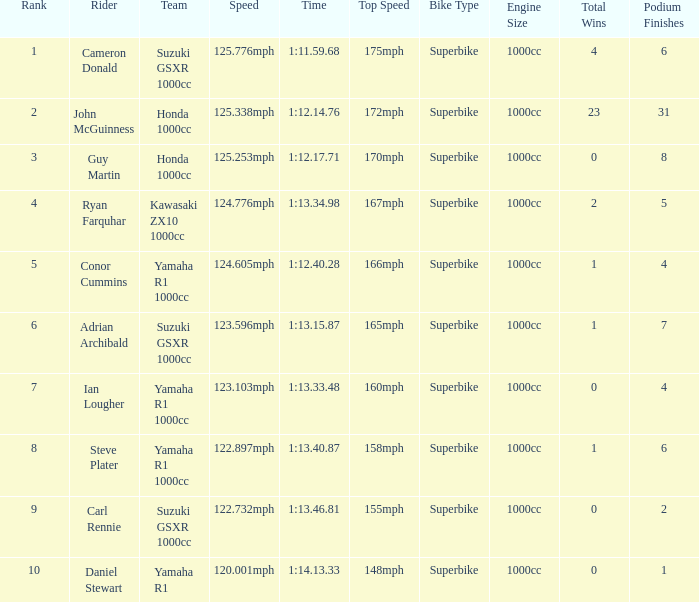What time did team kawasaki zx10 1000cc have? 1:13.34.98. 